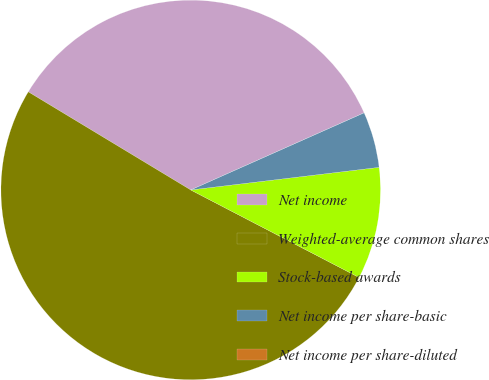Convert chart to OTSL. <chart><loc_0><loc_0><loc_500><loc_500><pie_chart><fcel>Net income<fcel>Weighted-average common shares<fcel>Stock-based awards<fcel>Net income per share-basic<fcel>Net income per share-diluted<nl><fcel>34.69%<fcel>51.02%<fcel>9.53%<fcel>4.76%<fcel>0.0%<nl></chart> 